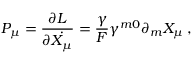<formula> <loc_0><loc_0><loc_500><loc_500>P _ { \mu } = \frac { \partial L } { \partial \dot { X _ { \mu } } } = \frac { \gamma } { F } \gamma ^ { m 0 } \partial _ { m } X _ { \mu } \, ,</formula> 